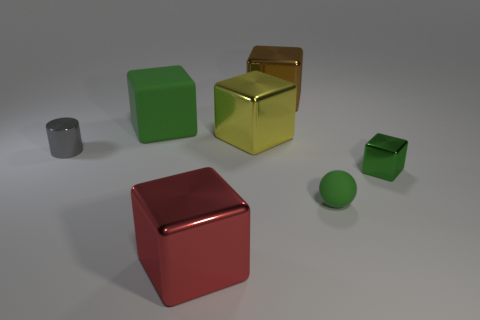What is the size of the matte object in front of the big green thing?
Offer a very short reply. Small. The cylinder that is made of the same material as the large red thing is what size?
Ensure brevity in your answer.  Small. Is the shape of the tiny rubber object the same as the matte thing behind the gray cylinder?
Give a very brief answer. No. There is a small shiny thing that is right of the green thing behind the large yellow block; how many rubber objects are on the right side of it?
Your response must be concise. 0. The small shiny thing that is the same shape as the large green rubber object is what color?
Your answer should be very brief. Green. Is there any other thing that is the same shape as the tiny matte object?
Your answer should be very brief. No. How many cylinders are tiny green rubber things or large red objects?
Give a very brief answer. 0. There is a tiny green rubber thing; what shape is it?
Provide a succinct answer. Sphere. There is a tiny cylinder; are there any green rubber balls behind it?
Offer a very short reply. No. Is the gray cylinder made of the same material as the green object that is behind the cylinder?
Your response must be concise. No. 